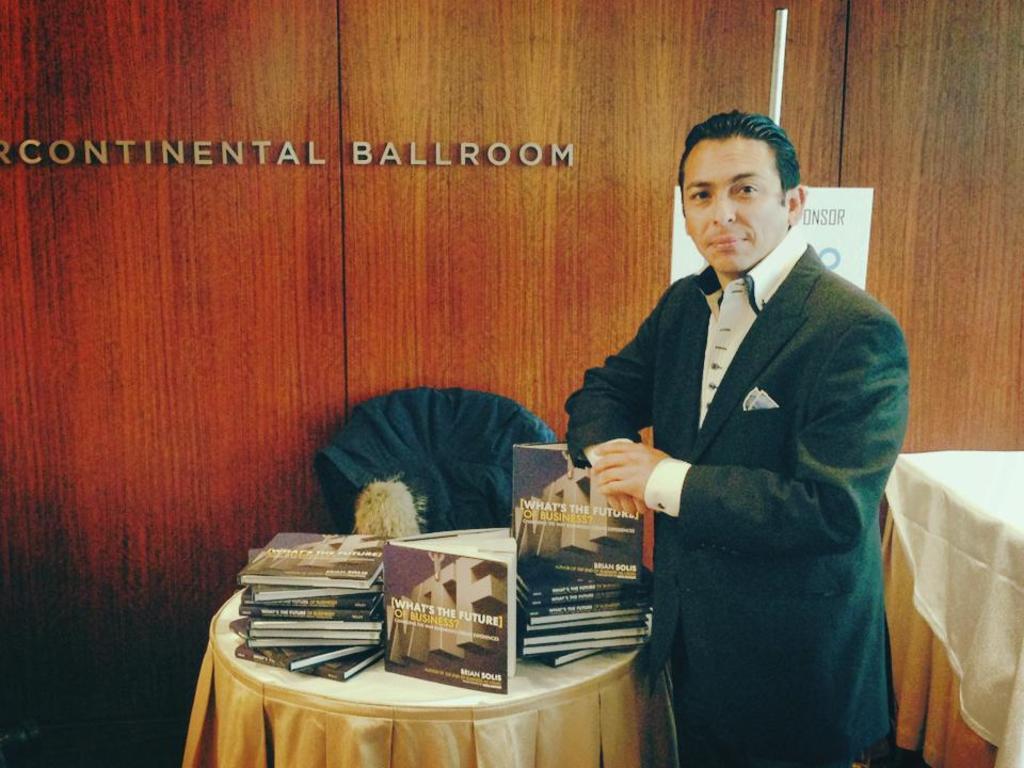Can you describe this image briefly? In this image we can see one man with smiling face standing near the table, two tables with table clothes, one chair with cloth, some books on the table in the middle of the image, one object on the table, some text on the wooden object, one white poster with text and one white object attached to the wooden object which looks like a wooden wall. 